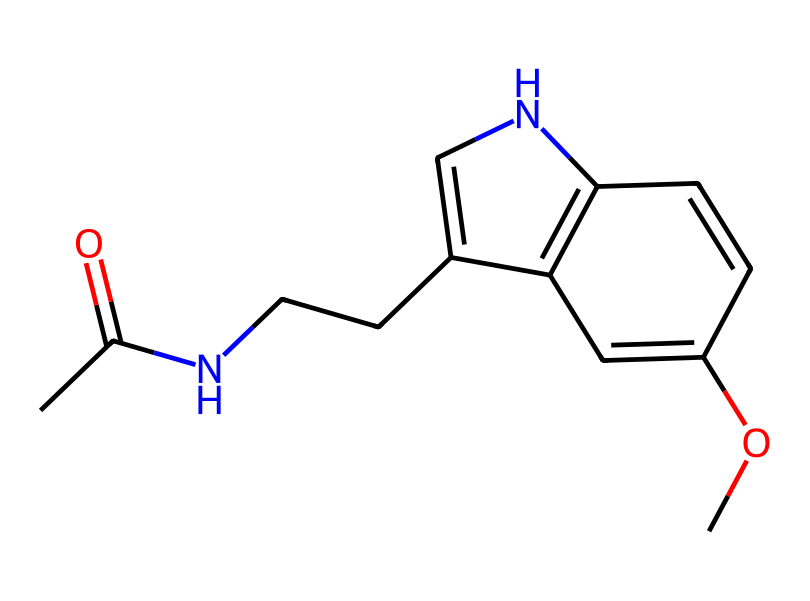How many carbon atoms are in the structure? By examining the SMILES representation, we can identify the carbon atoms, which are denoted by the letter 'C.' Counting the 'C's gives a total of eight carbon atoms.
Answer: eight What functional group is present in melatonin? The acetyl group (CC(=O)) indicates the presence of a carbonyl functional group (C=O) bonded to a methyl group (CH3). This shows that a functional group present is an amide.
Answer: amide How many nitrogen atoms are there in melatonin? The nitrogen atoms are represented by the letter 'N' in the SMILES notation. There are two instances of 'N' in the structure, indicating that there are two nitrogen atoms.
Answer: two What does the presence of an aromatic ring signify in this structure? The presence of a benzene ring is indicated by the alternating double bonds within the structure. Aromatic rings generally suggest stability and can affect the biological activity of the compound.
Answer: stability What type of drug is melatonin classified as based on its structure? Melatonin's structure, featuring an indole ring combined with an acetyl group, classifies it as a natural sleep aid, particularly a hormone that regulates sleep-wake cycles.
Answer: hormone What is the total number of rings in melatonin? Analyzing the rings present in the structure, there is a single indole ring that is commonly found in melatonin. Therefore, the total count of rings is one.
Answer: one How many oxygen atoms are in the chemical structure? The oxygen atoms are indicated by 'O' in the SMILES notation; there are two occurrences of 'O' in the structure, revealing that there are two oxygen atoms in melatonin.
Answer: two 